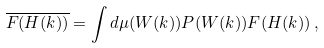<formula> <loc_0><loc_0><loc_500><loc_500>\overline { F ( H ( k ) ) } = \int d \mu ( W ( k ) ) P ( W ( k ) ) F ( H ( k ) ) \, ,</formula> 